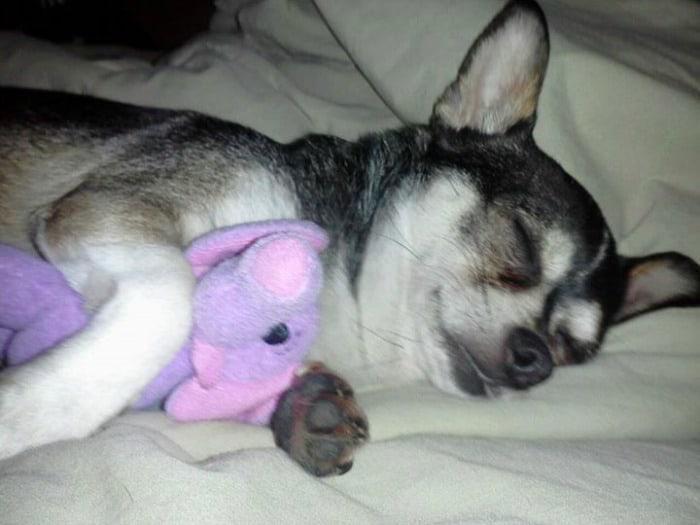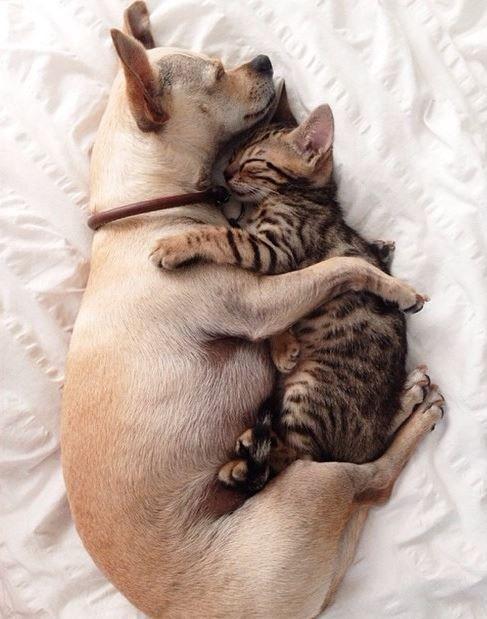The first image is the image on the left, the second image is the image on the right. Considering the images on both sides, is "A puppy with dark and light fur is sleeping with a dimensional object between its paws." valid? Answer yes or no. Yes. The first image is the image on the left, the second image is the image on the right. Evaluate the accuracy of this statement regarding the images: "In the left image, a dog is cuddling another object.". Is it true? Answer yes or no. Yes. 